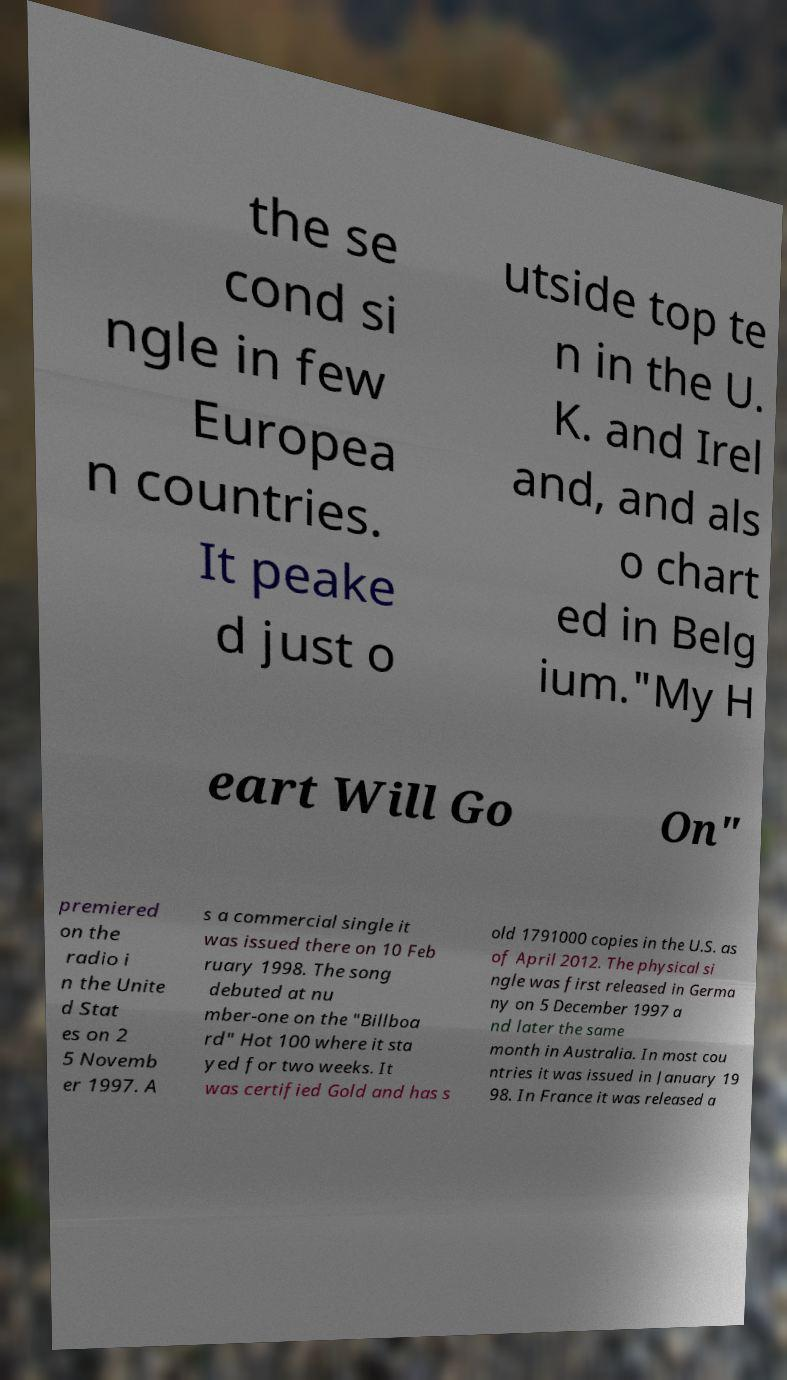What messages or text are displayed in this image? I need them in a readable, typed format. the se cond si ngle in few Europea n countries. It peake d just o utside top te n in the U. K. and Irel and, and als o chart ed in Belg ium."My H eart Will Go On" premiered on the radio i n the Unite d Stat es on 2 5 Novemb er 1997. A s a commercial single it was issued there on 10 Feb ruary 1998. The song debuted at nu mber-one on the "Billboa rd" Hot 100 where it sta yed for two weeks. It was certified Gold and has s old 1791000 copies in the U.S. as of April 2012. The physical si ngle was first released in Germa ny on 5 December 1997 a nd later the same month in Australia. In most cou ntries it was issued in January 19 98. In France it was released a 